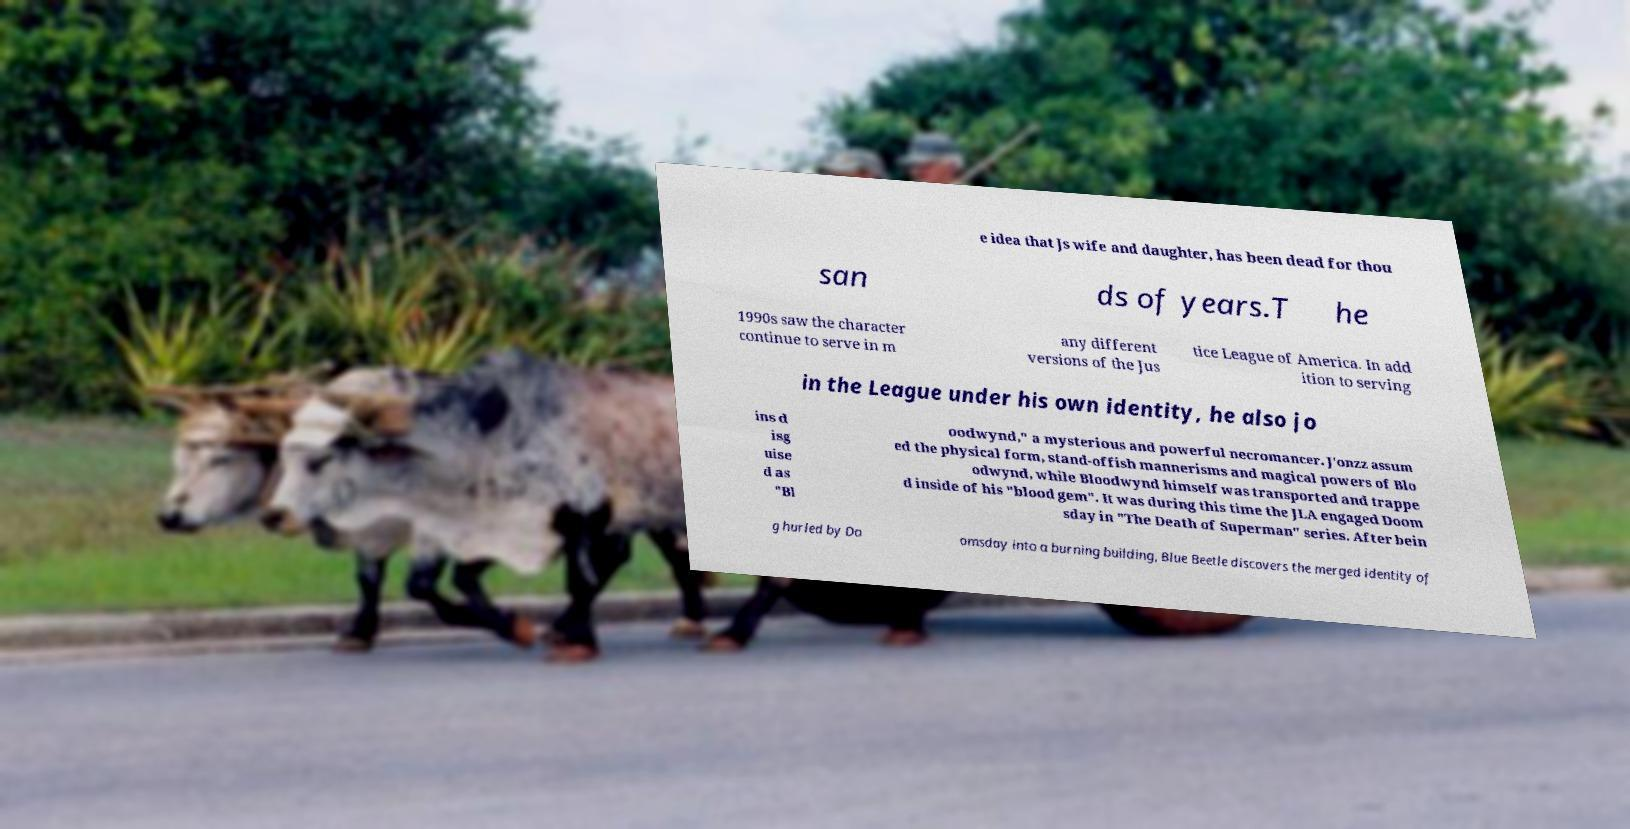Can you read and provide the text displayed in the image?This photo seems to have some interesting text. Can you extract and type it out for me? e idea that Js wife and daughter, has been dead for thou san ds of years.T he 1990s saw the character continue to serve in m any different versions of the Jus tice League of America. In add ition to serving in the League under his own identity, he also jo ins d isg uise d as "Bl oodwynd," a mysterious and powerful necromancer. J'onzz assum ed the physical form, stand-offish mannerisms and magical powers of Blo odwynd, while Bloodwynd himself was transported and trappe d inside of his "blood gem". It was during this time the JLA engaged Doom sday in "The Death of Superman" series. After bein g hurled by Do omsday into a burning building, Blue Beetle discovers the merged identity of 